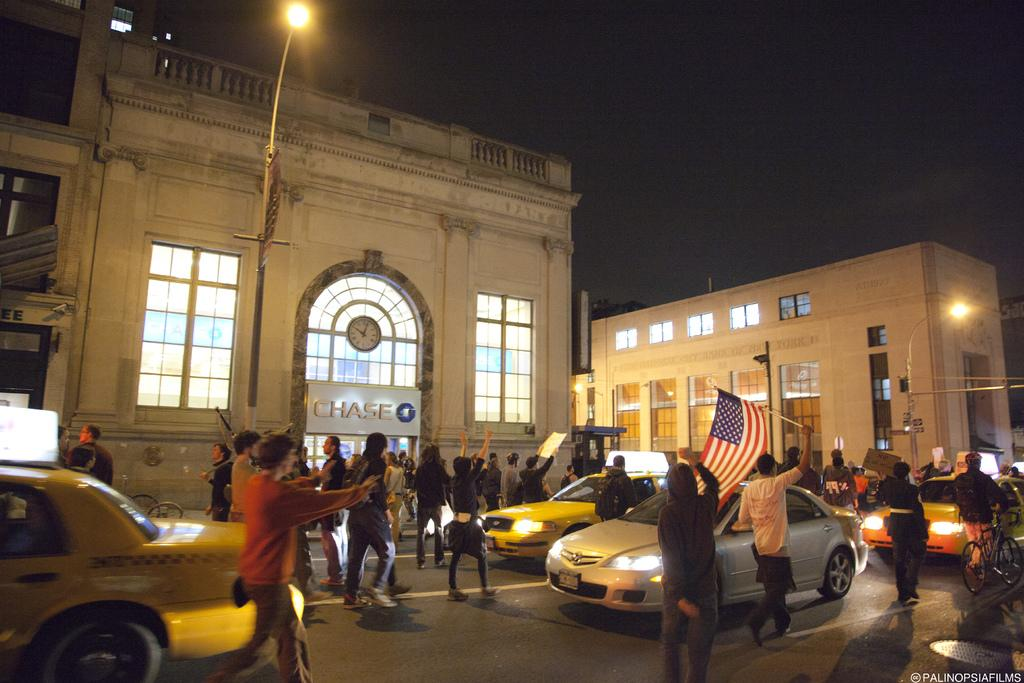<image>
Offer a succinct explanation of the picture presented. People gathered halting traffic outside of the Chase bank. 